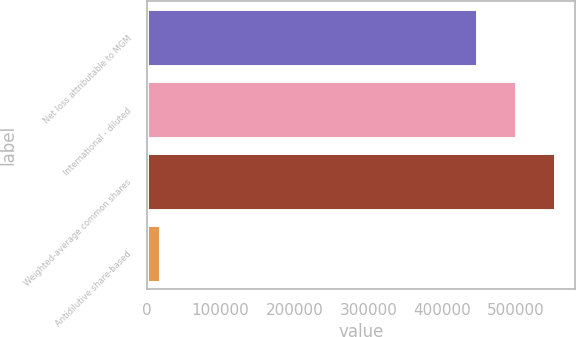Convert chart to OTSL. <chart><loc_0><loc_0><loc_500><loc_500><bar_chart><fcel>Net loss attributable to MGM<fcel>International - diluted<fcel>Weighted-average common shares<fcel>Antidilutive share-based<nl><fcel>447720<fcel>500180<fcel>552639<fcel>18276<nl></chart> 